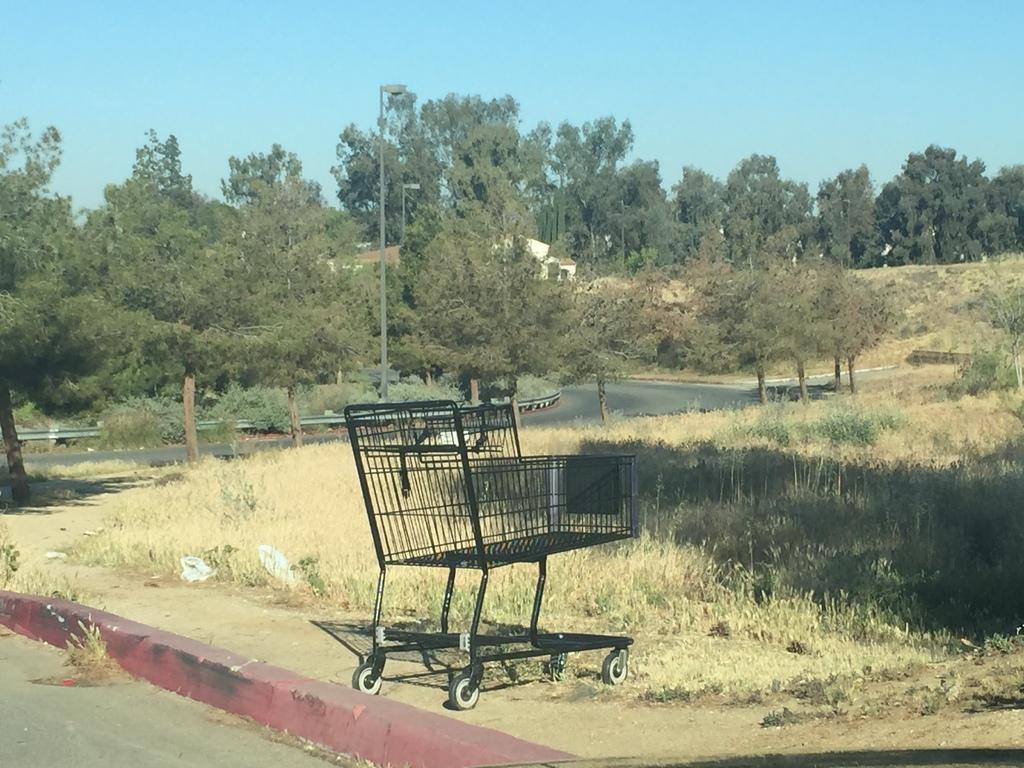How would you summarize this image in a sentence or two? In this image I can see the road, the ground, a black colored trolley, the railing, few trees which are green in color and few buildings. In the background I can see the sky. 